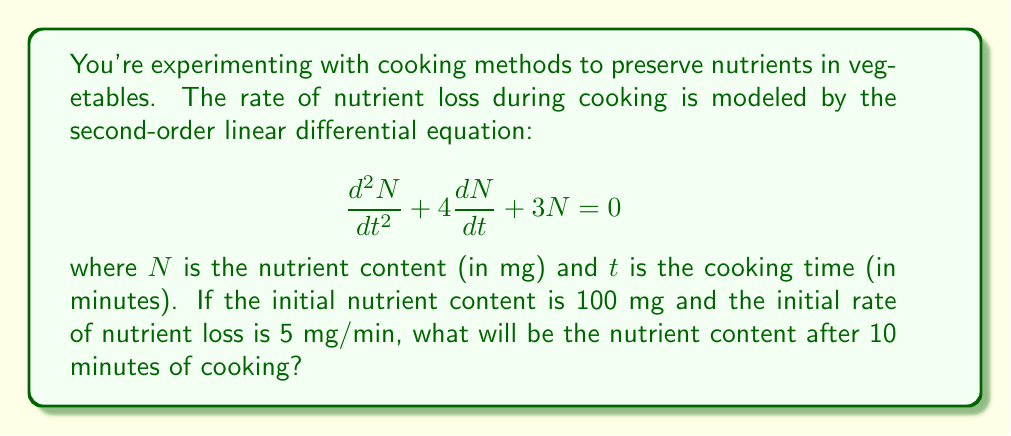Can you answer this question? To solve this problem, we need to follow these steps:

1) The general solution to this second-order linear differential equation is:

   $$N(t) = c_1e^{-t} + c_2e^{-3t}$$

2) We need to find $c_1$ and $c_2$ using the initial conditions:
   
   At $t=0$, $N(0) = 100$ and $\frac{dN}{dt}(0) = -5$

3) Using the first condition:

   $$100 = c_1 + c_2$$

4) For the second condition, we differentiate $N(t)$:

   $$\frac{dN}{dt} = -c_1e^{-t} - 3c_2e^{-3t}$$

   At $t=0$:
   
   $$-5 = -c_1 - 3c_2$$

5) Now we have a system of two equations:

   $$c_1 + c_2 = 100$$
   $$c_1 + 3c_2 = 5$$

6) Subtracting the second equation from the first:

   $$-2c_2 = 95$$
   $$c_2 = -47.5$$

7) Substituting back:

   $$c_1 = 100 - c_2 = 100 - (-47.5) = 147.5$$

8) Our solution is:

   $$N(t) = 147.5e^{-t} - 47.5e^{-3t}$$

9) To find the nutrient content after 10 minutes, we calculate $N(10)$:

   $$N(10) = 147.5e^{-10} - 47.5e^{-30}$$

10) Using a calculator:

    $$N(10) = 147.5 * 0.0000454 - 47.5 * 9.36 * 10^{-14} \approx 0.0067$$
Answer: The nutrient content after 10 minutes of cooking will be approximately 0.0067 mg. 